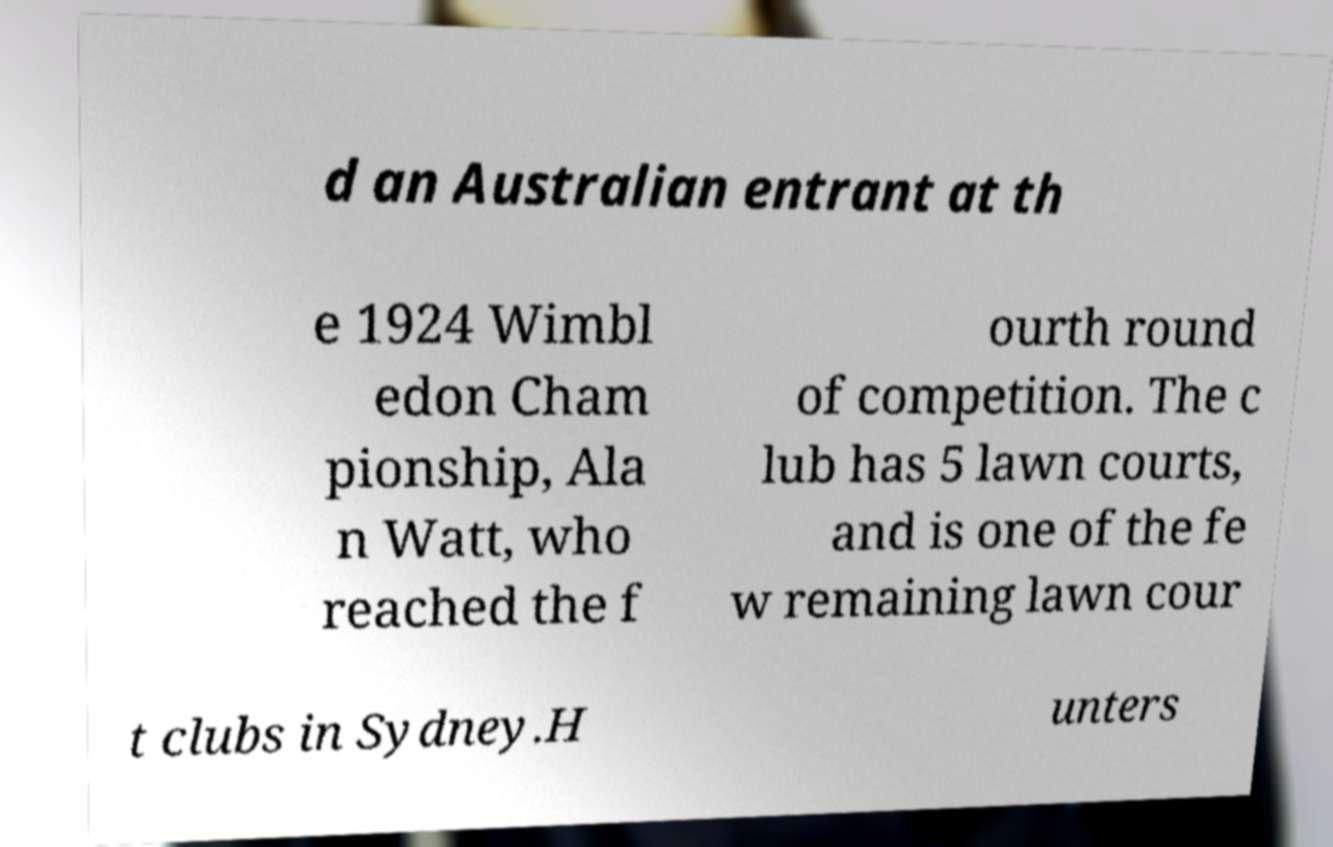I need the written content from this picture converted into text. Can you do that? d an Australian entrant at th e 1924 Wimbl edon Cham pionship, Ala n Watt, who reached the f ourth round of competition. The c lub has 5 lawn courts, and is one of the fe w remaining lawn cour t clubs in Sydney.H unters 